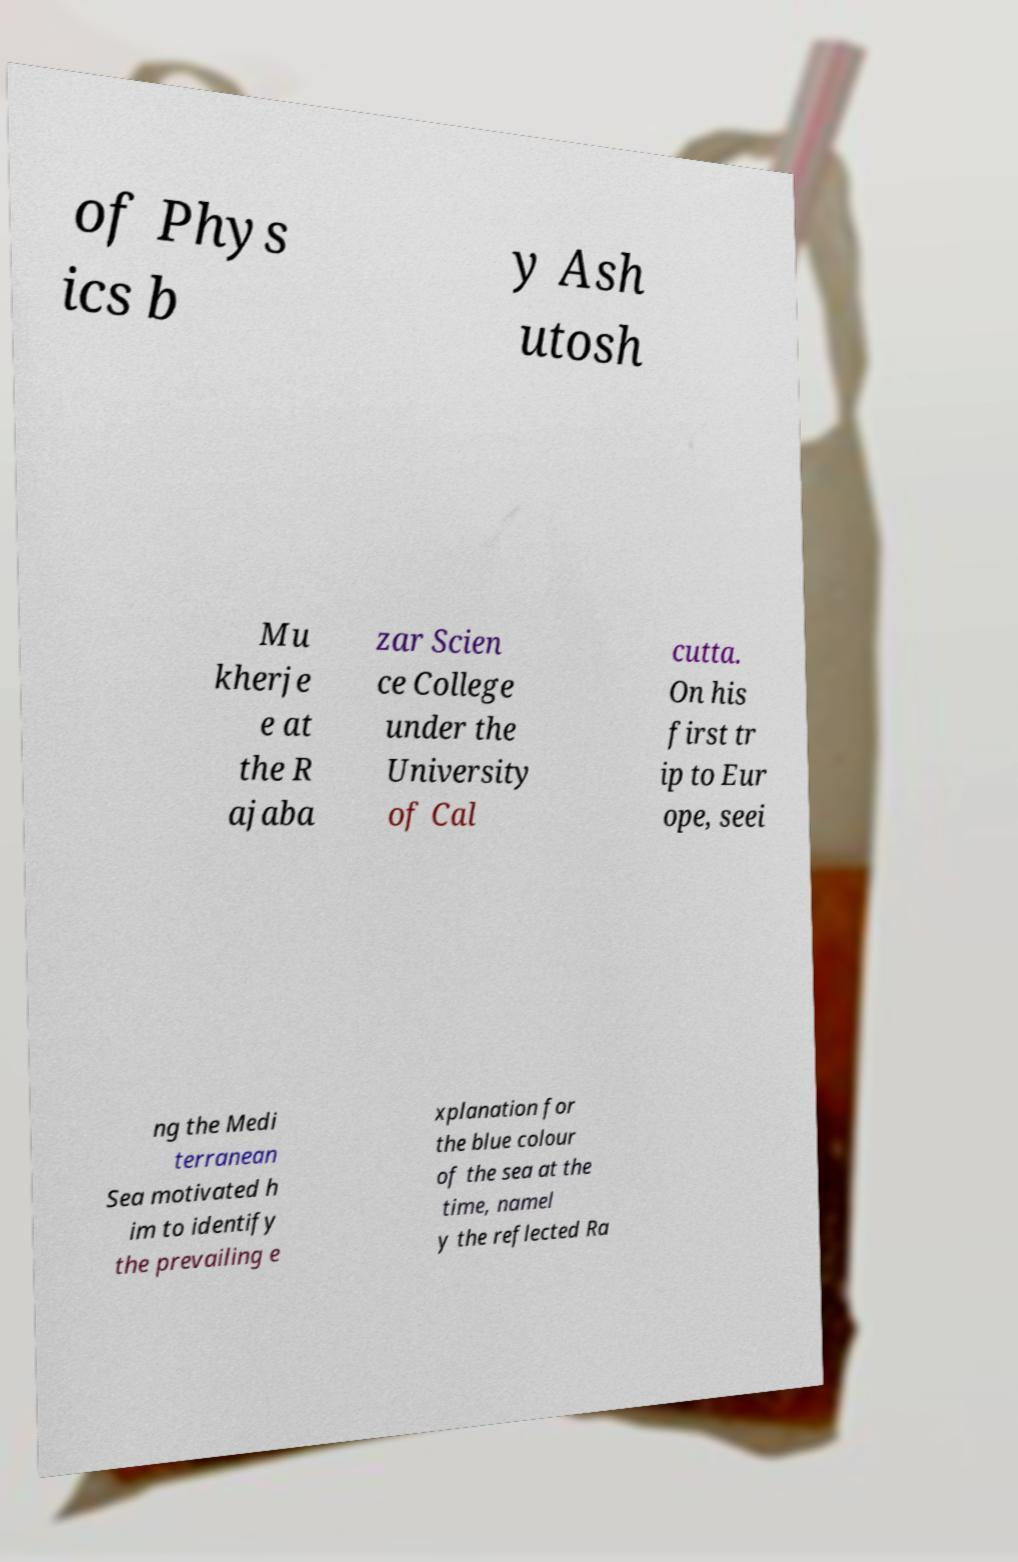Can you read and provide the text displayed in the image?This photo seems to have some interesting text. Can you extract and type it out for me? of Phys ics b y Ash utosh Mu kherje e at the R ajaba zar Scien ce College under the University of Cal cutta. On his first tr ip to Eur ope, seei ng the Medi terranean Sea motivated h im to identify the prevailing e xplanation for the blue colour of the sea at the time, namel y the reflected Ra 